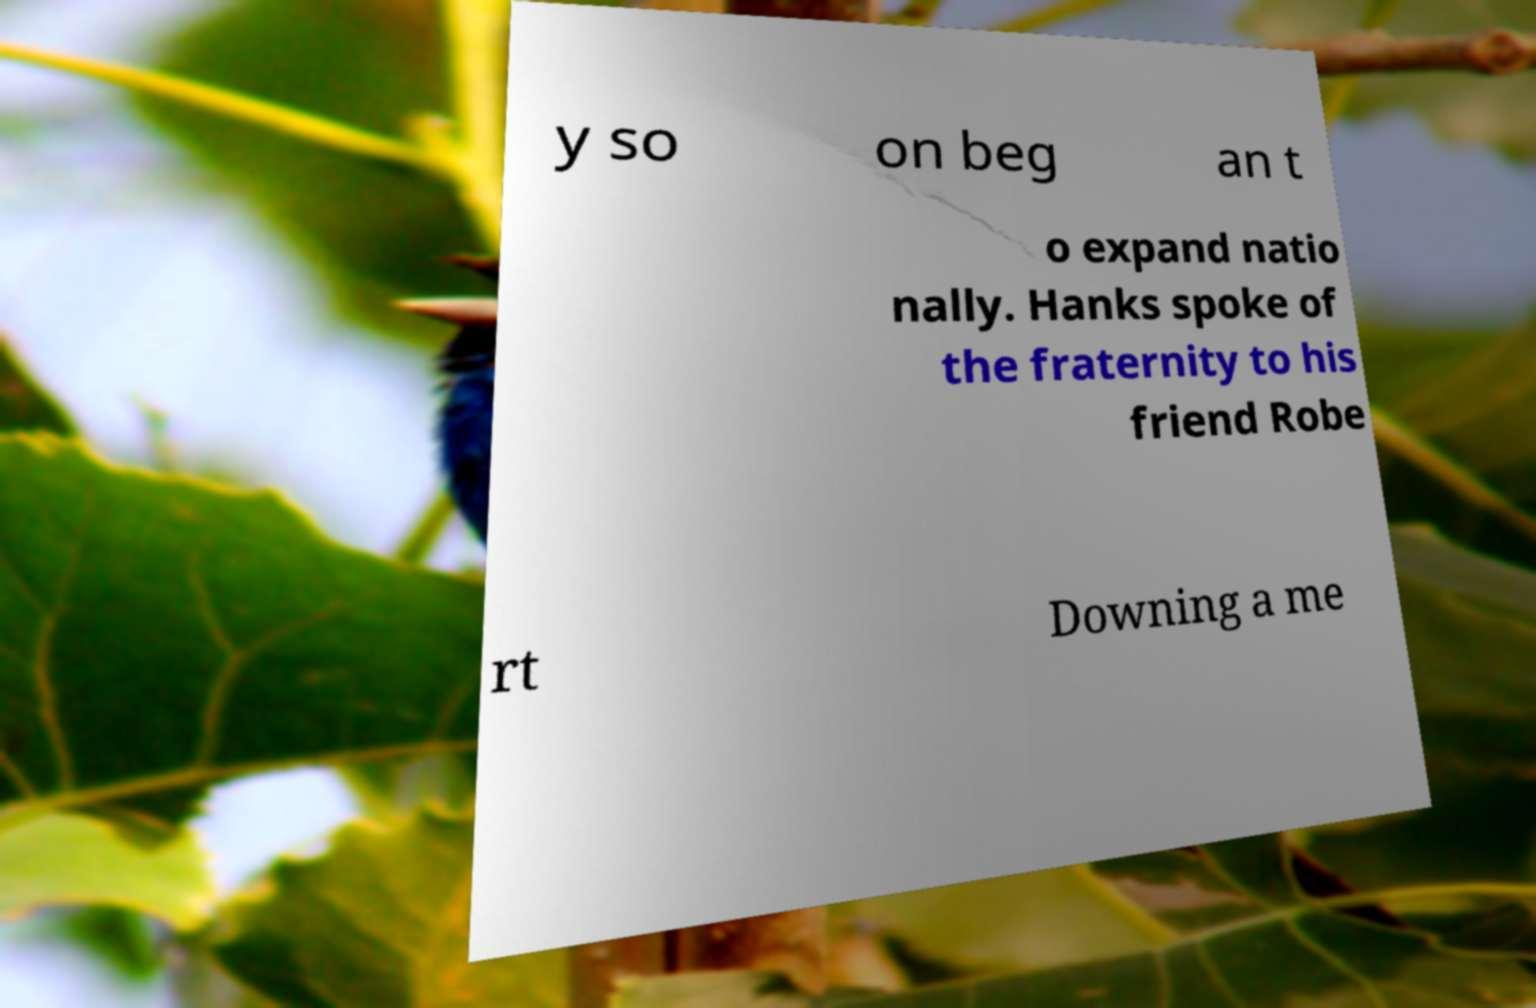I need the written content from this picture converted into text. Can you do that? y so on beg an t o expand natio nally. Hanks spoke of the fraternity to his friend Robe rt Downing a me 